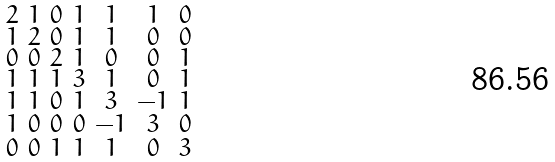<formula> <loc_0><loc_0><loc_500><loc_500>\begin{smallmatrix} 2 & 1 & 0 & 1 & 1 & 1 & 0 \\ 1 & 2 & 0 & 1 & 1 & 0 & 0 \\ 0 & 0 & 2 & 1 & 0 & 0 & 1 \\ 1 & 1 & 1 & 3 & 1 & 0 & 1 \\ 1 & 1 & 0 & 1 & 3 & - 1 & 1 \\ 1 & 0 & 0 & 0 & - 1 & 3 & 0 \\ 0 & 0 & 1 & 1 & 1 & 0 & 3 \end{smallmatrix}</formula> 